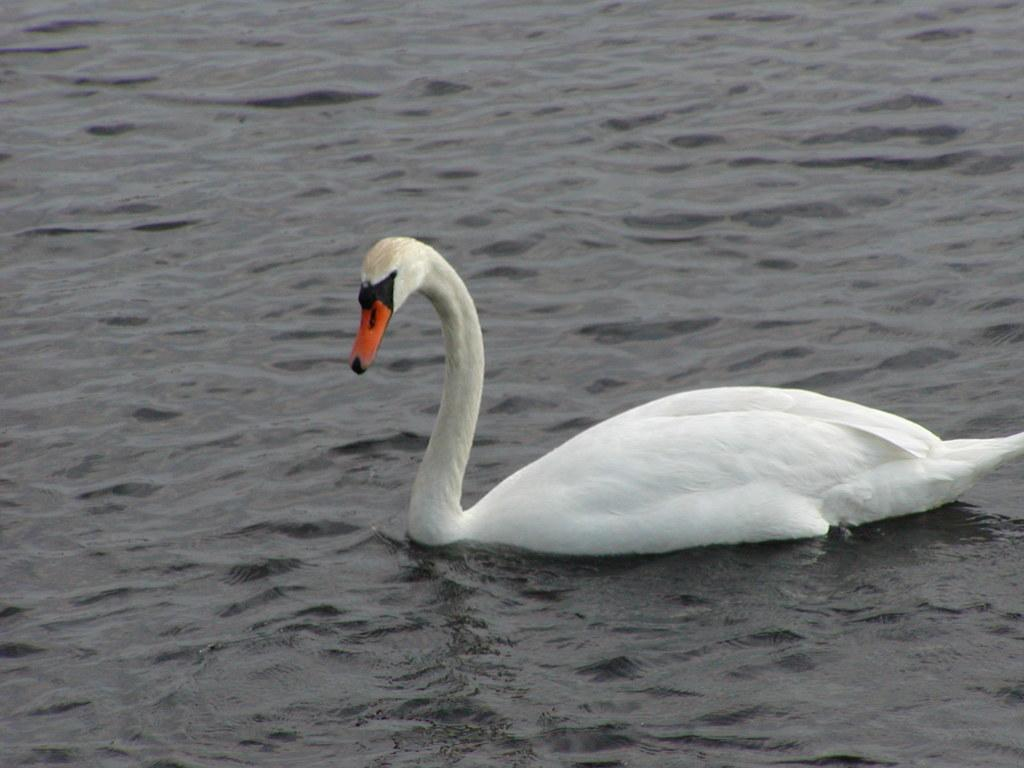What animal is present in the image? There is a swan in the image. Where is the swan located? The swan is on the water. What type of error can be seen in the image? There is no error present in the image; it features a swan on the water. What type of vest is the swan wearing in the image? The swan is not wearing a vest in the image, as swans do not wear clothing. 